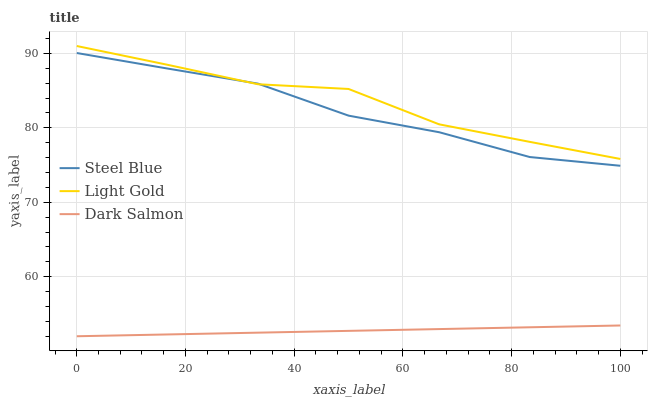Does Dark Salmon have the minimum area under the curve?
Answer yes or no. Yes. Does Light Gold have the maximum area under the curve?
Answer yes or no. Yes. Does Steel Blue have the minimum area under the curve?
Answer yes or no. No. Does Steel Blue have the maximum area under the curve?
Answer yes or no. No. Is Dark Salmon the smoothest?
Answer yes or no. Yes. Is Light Gold the roughest?
Answer yes or no. Yes. Is Steel Blue the smoothest?
Answer yes or no. No. Is Steel Blue the roughest?
Answer yes or no. No. Does Steel Blue have the lowest value?
Answer yes or no. No. Does Steel Blue have the highest value?
Answer yes or no. No. Is Dark Salmon less than Light Gold?
Answer yes or no. Yes. Is Steel Blue greater than Dark Salmon?
Answer yes or no. Yes. Does Dark Salmon intersect Light Gold?
Answer yes or no. No. 